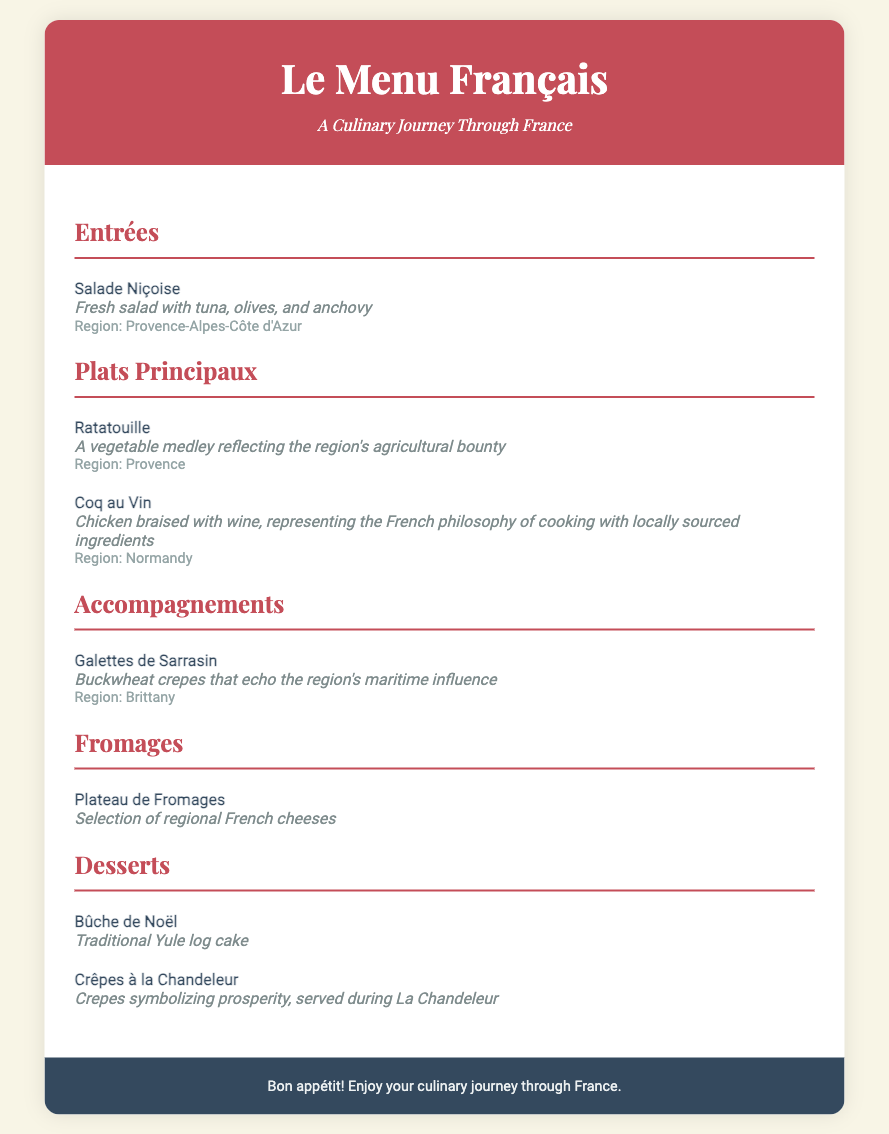What are the two key ingredients in Salade Niçoise? The ingredients are tuna and olives, which are highlighted in the dish description.
Answer: Tuna, olives Which dish is a traditional Yule log cake? The dessert section specifies that Bûche de Noël is the traditional Yule log cake.
Answer: Bûche de Noël What region is associated with Ratatouille? The region is mentioned in the dish description for Ratatouille, indicating its origin.
Answer: Provence What do Crêpes à la Chandeleur symbolize? The dish description for Crêpes à la Chandeleur states they symbolize prosperity.
Answer: Prosperity How many main courses are listed in the menu? By counting the dishes under the Plats Principaux section, there are two main courses provided.
Answer: 2 Which accompaniment echoes the region’s maritime influence? The description under Accompagnements states that Galettes de Sarrasin reflects the maritime influence.
Answer: Galettes de Sarrasin What type of cheese selection is mentioned in the menu? The Fromages section describes a selection of regional French cheeses.
Answer: Regional French cheeses From which region does Coq au Vin originate? The region is specified in the dish description for Coq au Vin.
Answer: Normandy 